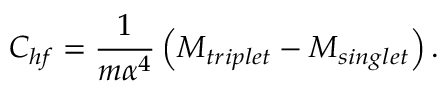Convert formula to latex. <formula><loc_0><loc_0><loc_500><loc_500>C _ { h f } = \frac { 1 } { m \alpha ^ { 4 } } \left ( M _ { t r i p l e t } - M _ { \sin g l e t } \right ) .</formula> 